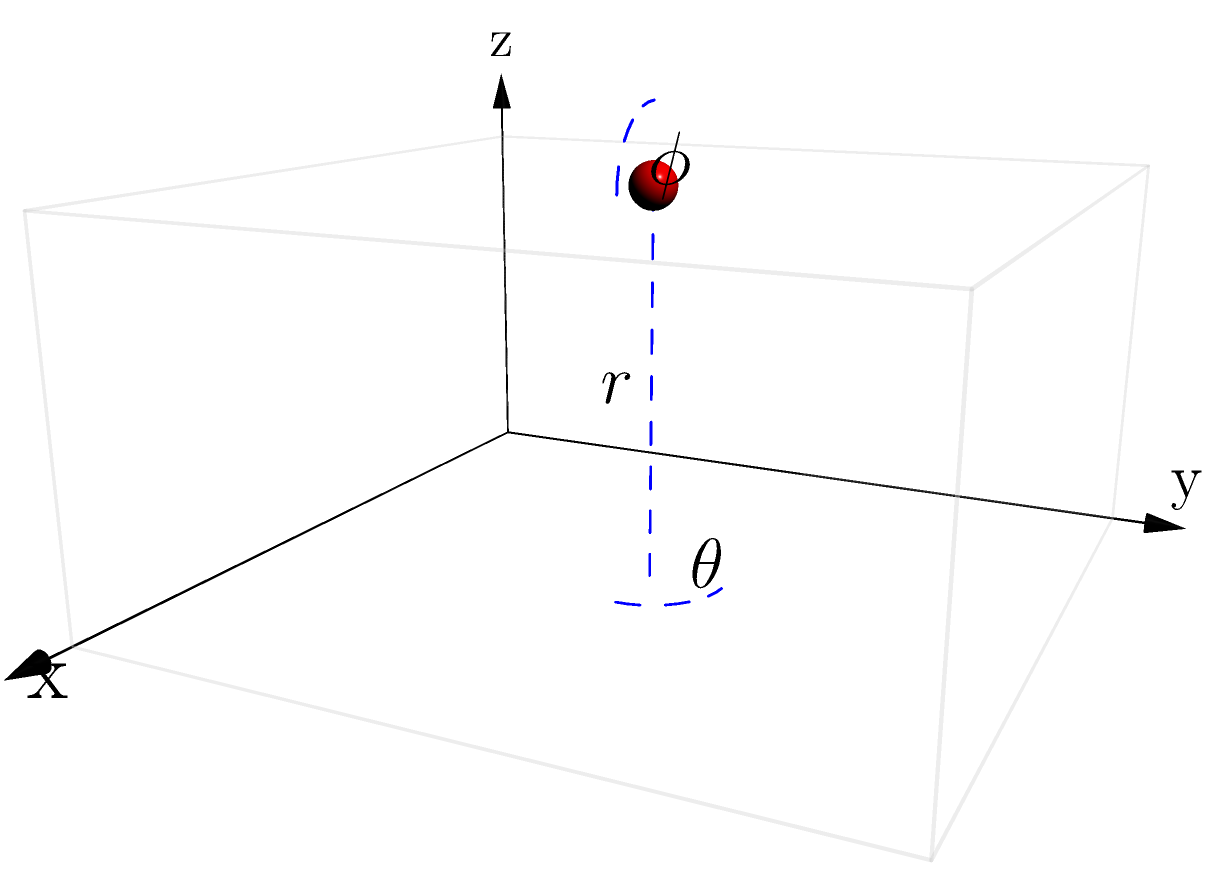In a smart building project, you need to optimize the placement of sensors for maximum coverage. Consider a rectangular room with dimensions 10m x 10m x 5m. Using spherical coordinates $(r, \theta, \phi)$, where $r$ is the distance from the origin, $\theta$ is the azimuthal angle in the x-y plane from the x-axis (0 ≤ θ < 2π), and $\phi$ is the polar angle from the z-axis (0 ≤ φ ≤ π), determine the optimal position for a single sensor to be placed at the center of the room's ceiling. What are the spherical coordinates of this position? To determine the optimal position for the sensor, we'll follow these steps:

1) The origin (0,0,0) is at one corner of the room.

2) The center of the ceiling will be:
   x = 10/2 = 5m
   y = 10/2 = 5m
   z = 5m (height of the room)

3) Now, we need to convert these Cartesian coordinates (5,5,5) to spherical coordinates (r,θ,φ).

4) For r (distance from origin):
   $$r = \sqrt{x^2 + y^2 + z^2} = \sqrt{5^2 + 5^2 + 5^2} = 5\sqrt{3} \approx 8.66\text{ m}$$

5) For θ (azimuthal angle):
   $$\theta = \arctan(\frac{y}{x}) = \arctan(\frac{5}{5}) = \arctan(1) = \frac{\pi}{4} \approx 0.785\text{ radians}$$

6) For φ (polar angle):
   $$\phi = \arccos(\frac{z}{r}) = \arccos(\frac{5}{5\sqrt{3}}) = \arccos(\frac{1}{\sqrt{3}}) \approx 0.955\text{ radians}$$

Therefore, the spherical coordinates of the optimal sensor position are $(5\sqrt{3}, \frac{\pi}{4}, \arccos(\frac{1}{\sqrt{3}}))$.
Answer: $(5\sqrt{3}, \frac{\pi}{4}, \arccos(\frac{1}{\sqrt{3}}))$ 